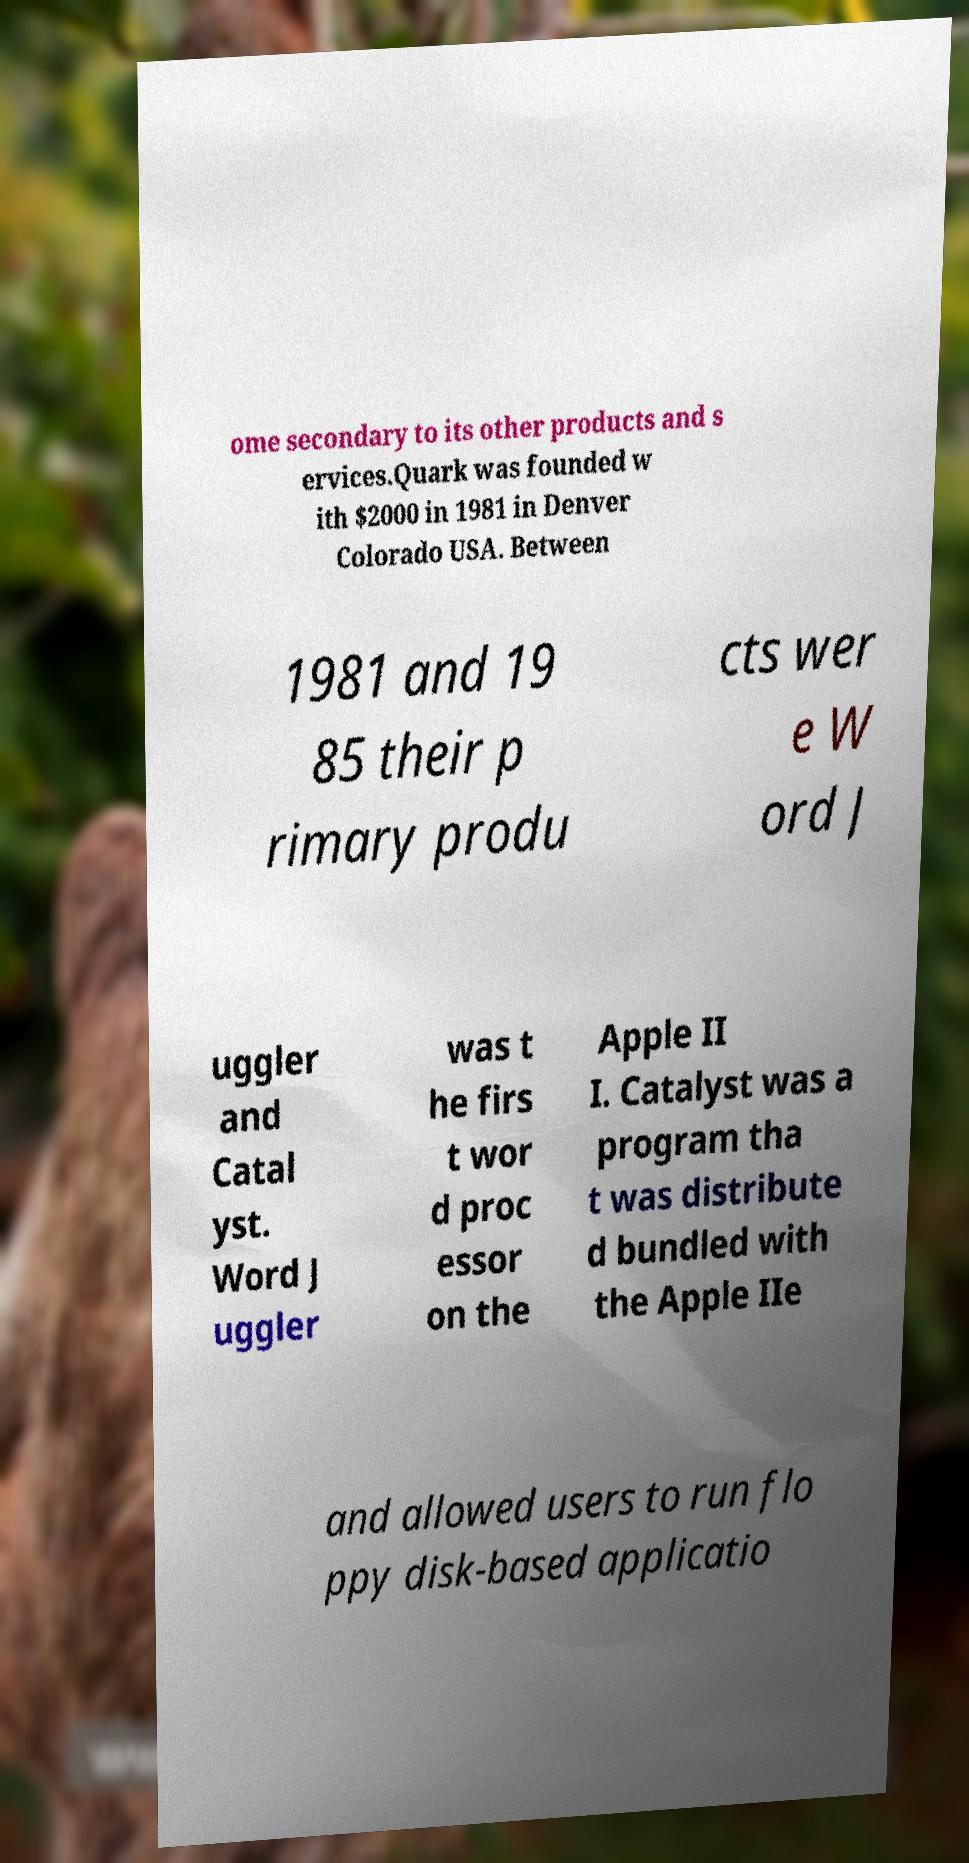There's text embedded in this image that I need extracted. Can you transcribe it verbatim? ome secondary to its other products and s ervices.Quark was founded w ith $2000 in 1981 in Denver Colorado USA. Between 1981 and 19 85 their p rimary produ cts wer e W ord J uggler and Catal yst. Word J uggler was t he firs t wor d proc essor on the Apple II I. Catalyst was a program tha t was distribute d bundled with the Apple IIe and allowed users to run flo ppy disk-based applicatio 